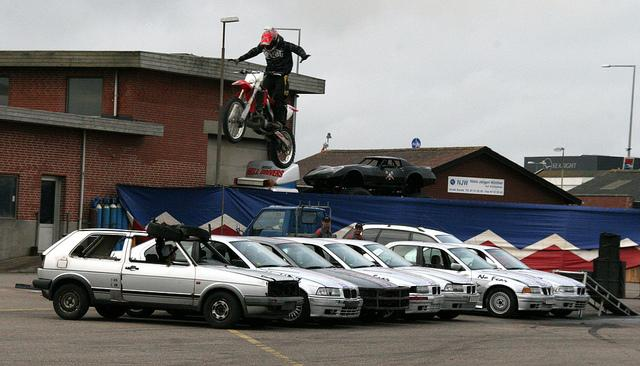Why is he in midair? Please explain your reasoning. showing off. The rider is holding his hands away from the bike as part of a display, demonstrating his prowess and fearlessness. this is a common feature of daredevil stunt performances. 